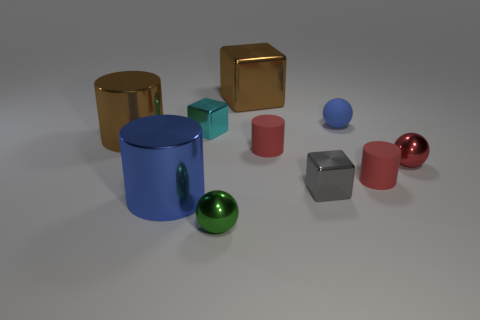Is the number of small gray objects that are behind the gray cube less than the number of gray shiny cubes that are behind the tiny red ball?
Offer a terse response. No. There is a large cube that is the same material as the tiny green object; what color is it?
Give a very brief answer. Brown. Are there any big brown objects that are behind the brown metallic object right of the green sphere?
Provide a succinct answer. No. The other cube that is the same size as the cyan metal cube is what color?
Your response must be concise. Gray. What number of objects are either large purple cylinders or blue shiny things?
Ensure brevity in your answer.  1. There is a brown thing on the right side of the cyan object that is behind the brown object that is left of the tiny green metallic sphere; what is its size?
Ensure brevity in your answer.  Large. How many shiny cylinders are the same color as the large block?
Your answer should be very brief. 1. How many small gray things have the same material as the green ball?
Your answer should be compact. 1. What number of objects are brown metallic blocks or small red rubber cylinders that are right of the blue rubber thing?
Your answer should be very brief. 2. There is a block on the right side of the red rubber cylinder behind the tiny metal sphere right of the green ball; what is its color?
Make the answer very short. Gray. 